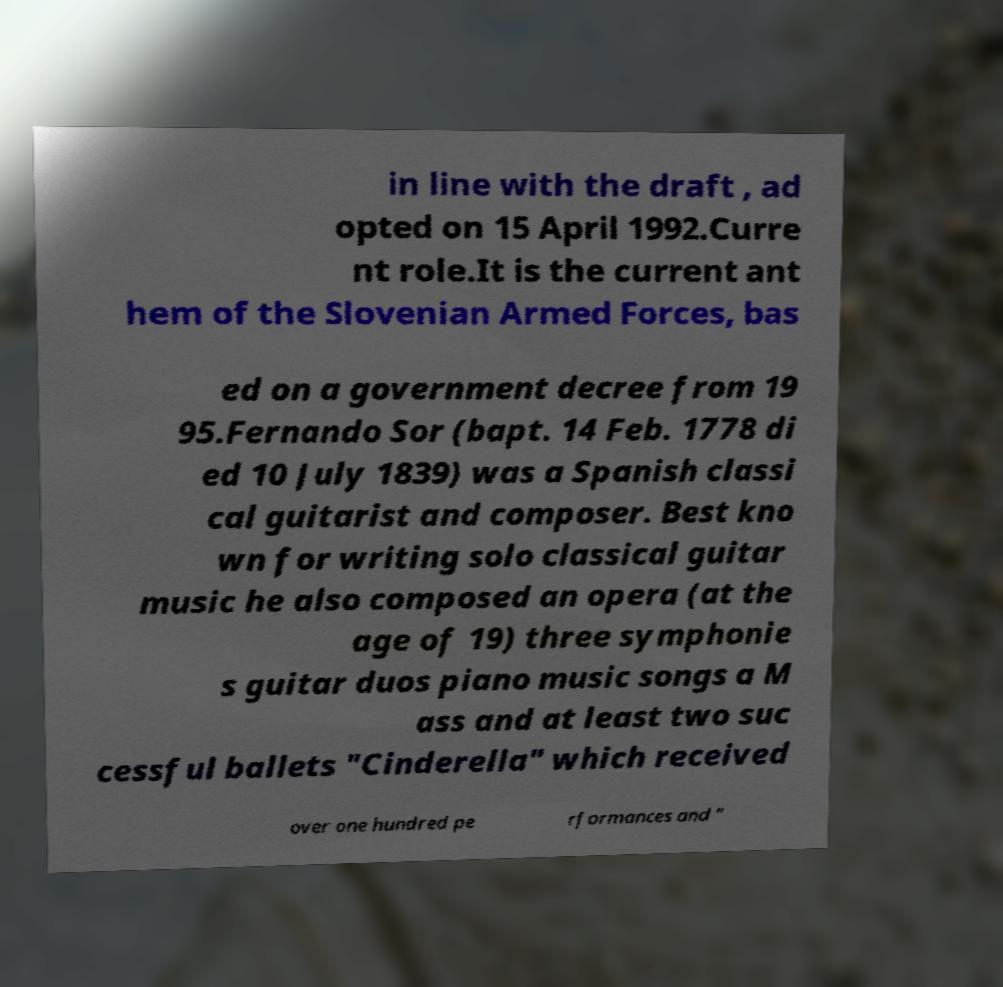Can you read and provide the text displayed in the image?This photo seems to have some interesting text. Can you extract and type it out for me? in line with the draft , ad opted on 15 April 1992.Curre nt role.It is the current ant hem of the Slovenian Armed Forces, bas ed on a government decree from 19 95.Fernando Sor (bapt. 14 Feb. 1778 di ed 10 July 1839) was a Spanish classi cal guitarist and composer. Best kno wn for writing solo classical guitar music he also composed an opera (at the age of 19) three symphonie s guitar duos piano music songs a M ass and at least two suc cessful ballets "Cinderella" which received over one hundred pe rformances and " 